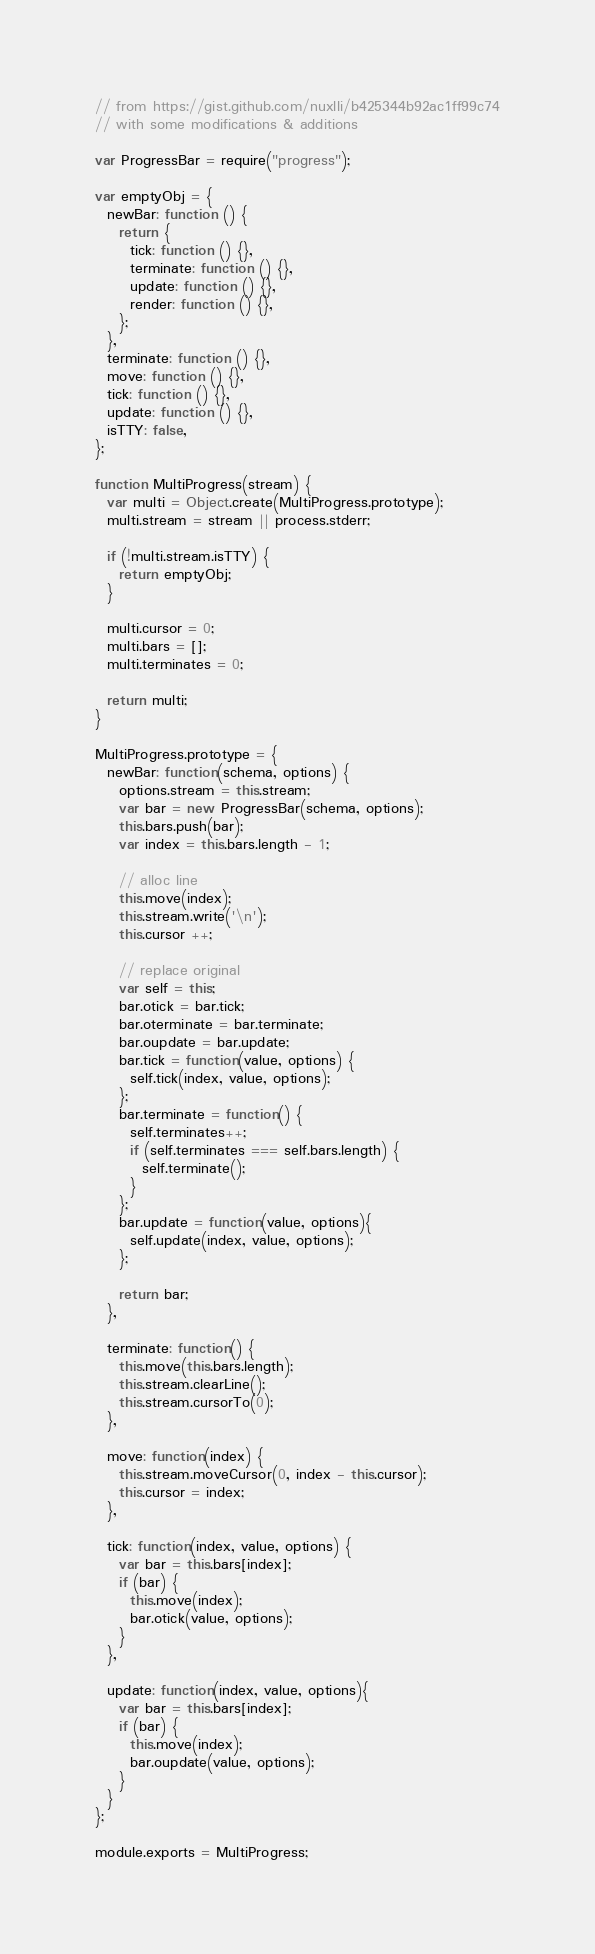Convert code to text. <code><loc_0><loc_0><loc_500><loc_500><_JavaScript_>// from https://gist.github.com/nuxlli/b425344b92ac1ff99c74
// with some modifications & additions

var ProgressBar = require("progress");

var emptyObj = {
  newBar: function () {
    return {
      tick: function () {},
      terminate: function () {},
      update: function () {},
      render: function () {},
    };
  },
  terminate: function () {},
  move: function () {},
  tick: function () {},
  update: function () {},
  isTTY: false,
};

function MultiProgress(stream) {
  var multi = Object.create(MultiProgress.prototype);
  multi.stream = stream || process.stderr;
  
  if (!multi.stream.isTTY) {
    return emptyObj;
  }
  
  multi.cursor = 0;
  multi.bars = [];
  multi.terminates = 0;

  return multi;
}

MultiProgress.prototype = {
  newBar: function(schema, options) {
    options.stream = this.stream;
    var bar = new ProgressBar(schema, options);
    this.bars.push(bar);
    var index = this.bars.length - 1;

    // alloc line
    this.move(index);
    this.stream.write('\n');
    this.cursor ++;

    // replace original
    var self = this;
    bar.otick = bar.tick;
    bar.oterminate = bar.terminate;
    bar.oupdate = bar.update;
    bar.tick = function(value, options) {
      self.tick(index, value, options);
    };
    bar.terminate = function() {
      self.terminates++;
      if (self.terminates === self.bars.length) {
        self.terminate();
      }
    };
    bar.update = function(value, options){
      self.update(index, value, options);
    };

    return bar;
  },

  terminate: function() {
    this.move(this.bars.length);
    this.stream.clearLine();
    this.stream.cursorTo(0);
  },

  move: function(index) {
    this.stream.moveCursor(0, index - this.cursor);
    this.cursor = index;
  },

  tick: function(index, value, options) {
    var bar = this.bars[index];
    if (bar) {
      this.move(index);
      bar.otick(value, options);
    }
  },

  update: function(index, value, options){
    var bar = this.bars[index];
    if (bar) {
      this.move(index);
      bar.oupdate(value, options);
    }
  }
};

module.exports = MultiProgress;</code> 